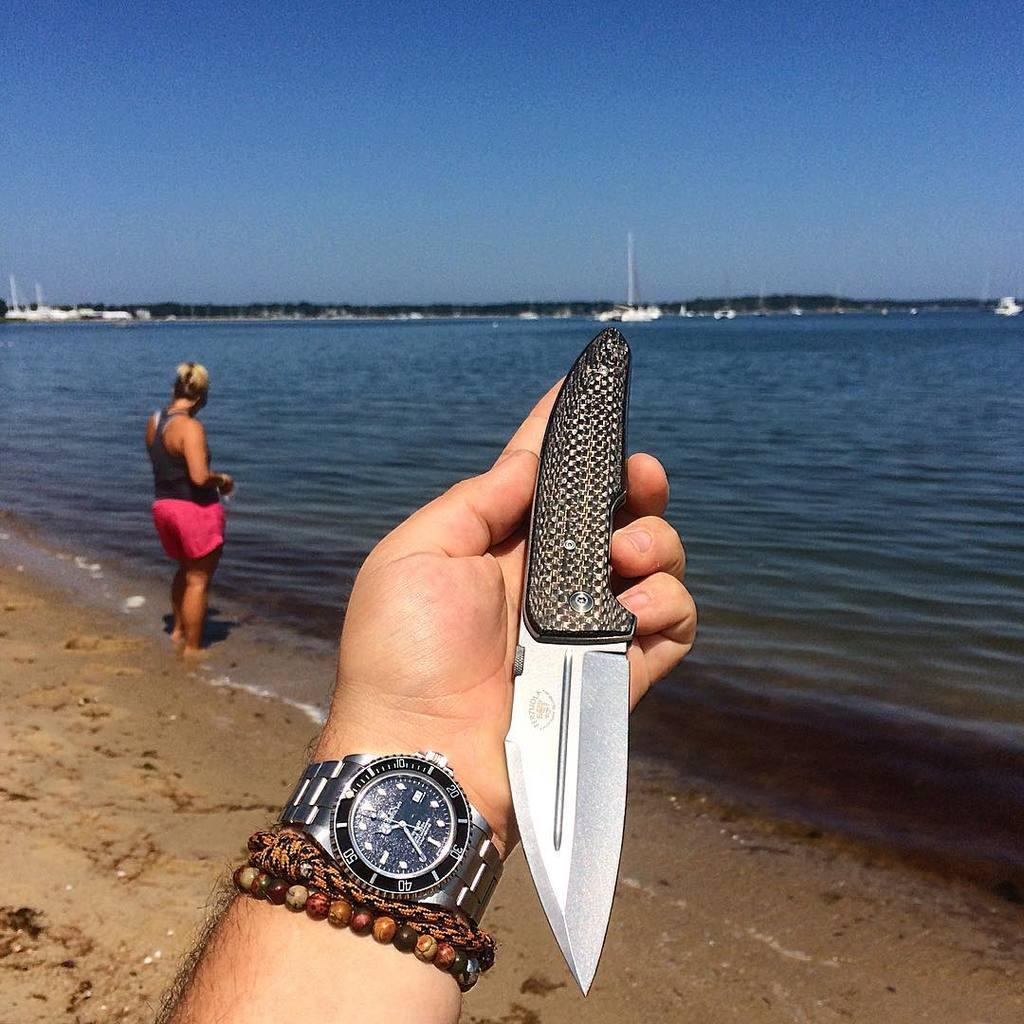<image>
Give a short and clear explanation of the subsequent image. A knife and a watch are in someone's hand at the beach; the time is 10:35. 